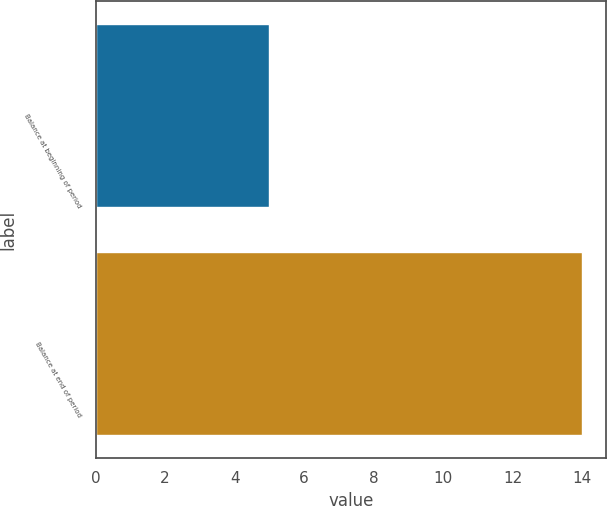<chart> <loc_0><loc_0><loc_500><loc_500><bar_chart><fcel>Balance at beginning of period<fcel>Balance at end of period<nl><fcel>5<fcel>14<nl></chart> 